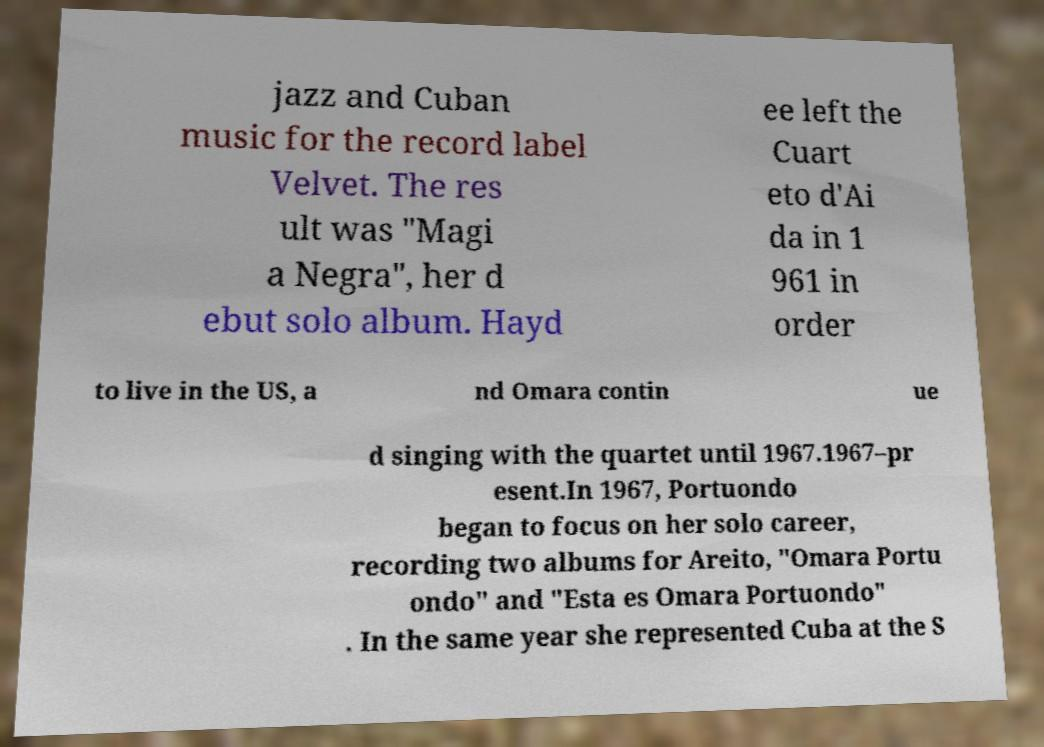Can you read and provide the text displayed in the image?This photo seems to have some interesting text. Can you extract and type it out for me? jazz and Cuban music for the record label Velvet. The res ult was "Magi a Negra", her d ebut solo album. Hayd ee left the Cuart eto d'Ai da in 1 961 in order to live in the US, a nd Omara contin ue d singing with the quartet until 1967.1967–pr esent.In 1967, Portuondo began to focus on her solo career, recording two albums for Areito, "Omara Portu ondo" and "Esta es Omara Portuondo" . In the same year she represented Cuba at the S 